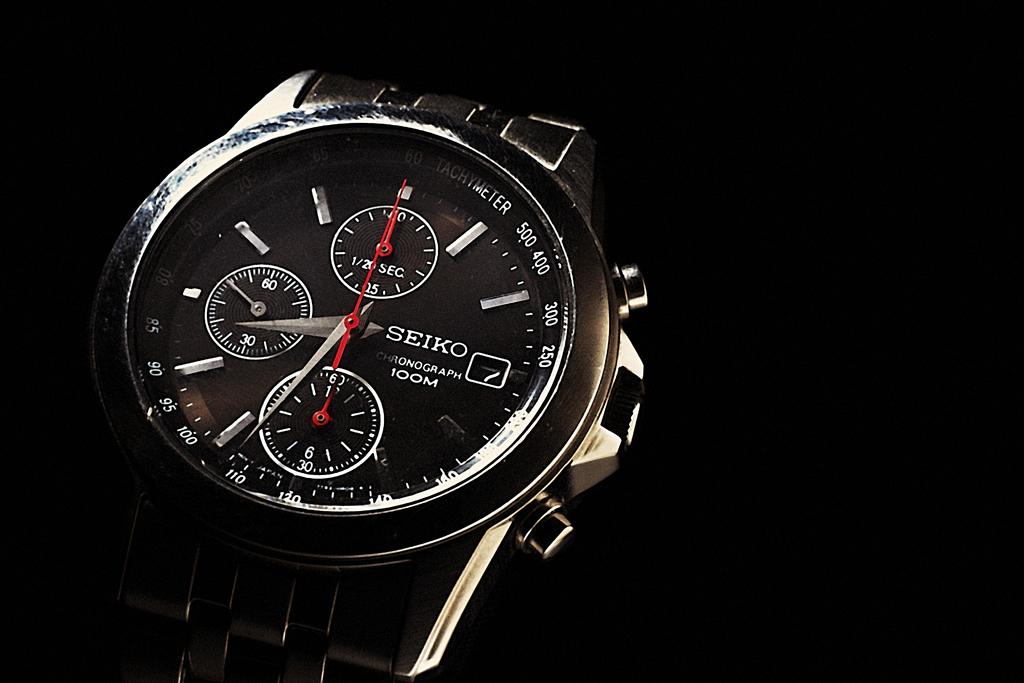What time is it?
Provide a short and direct response. 8:34. What watch it is?
Your answer should be very brief. Seiko. 